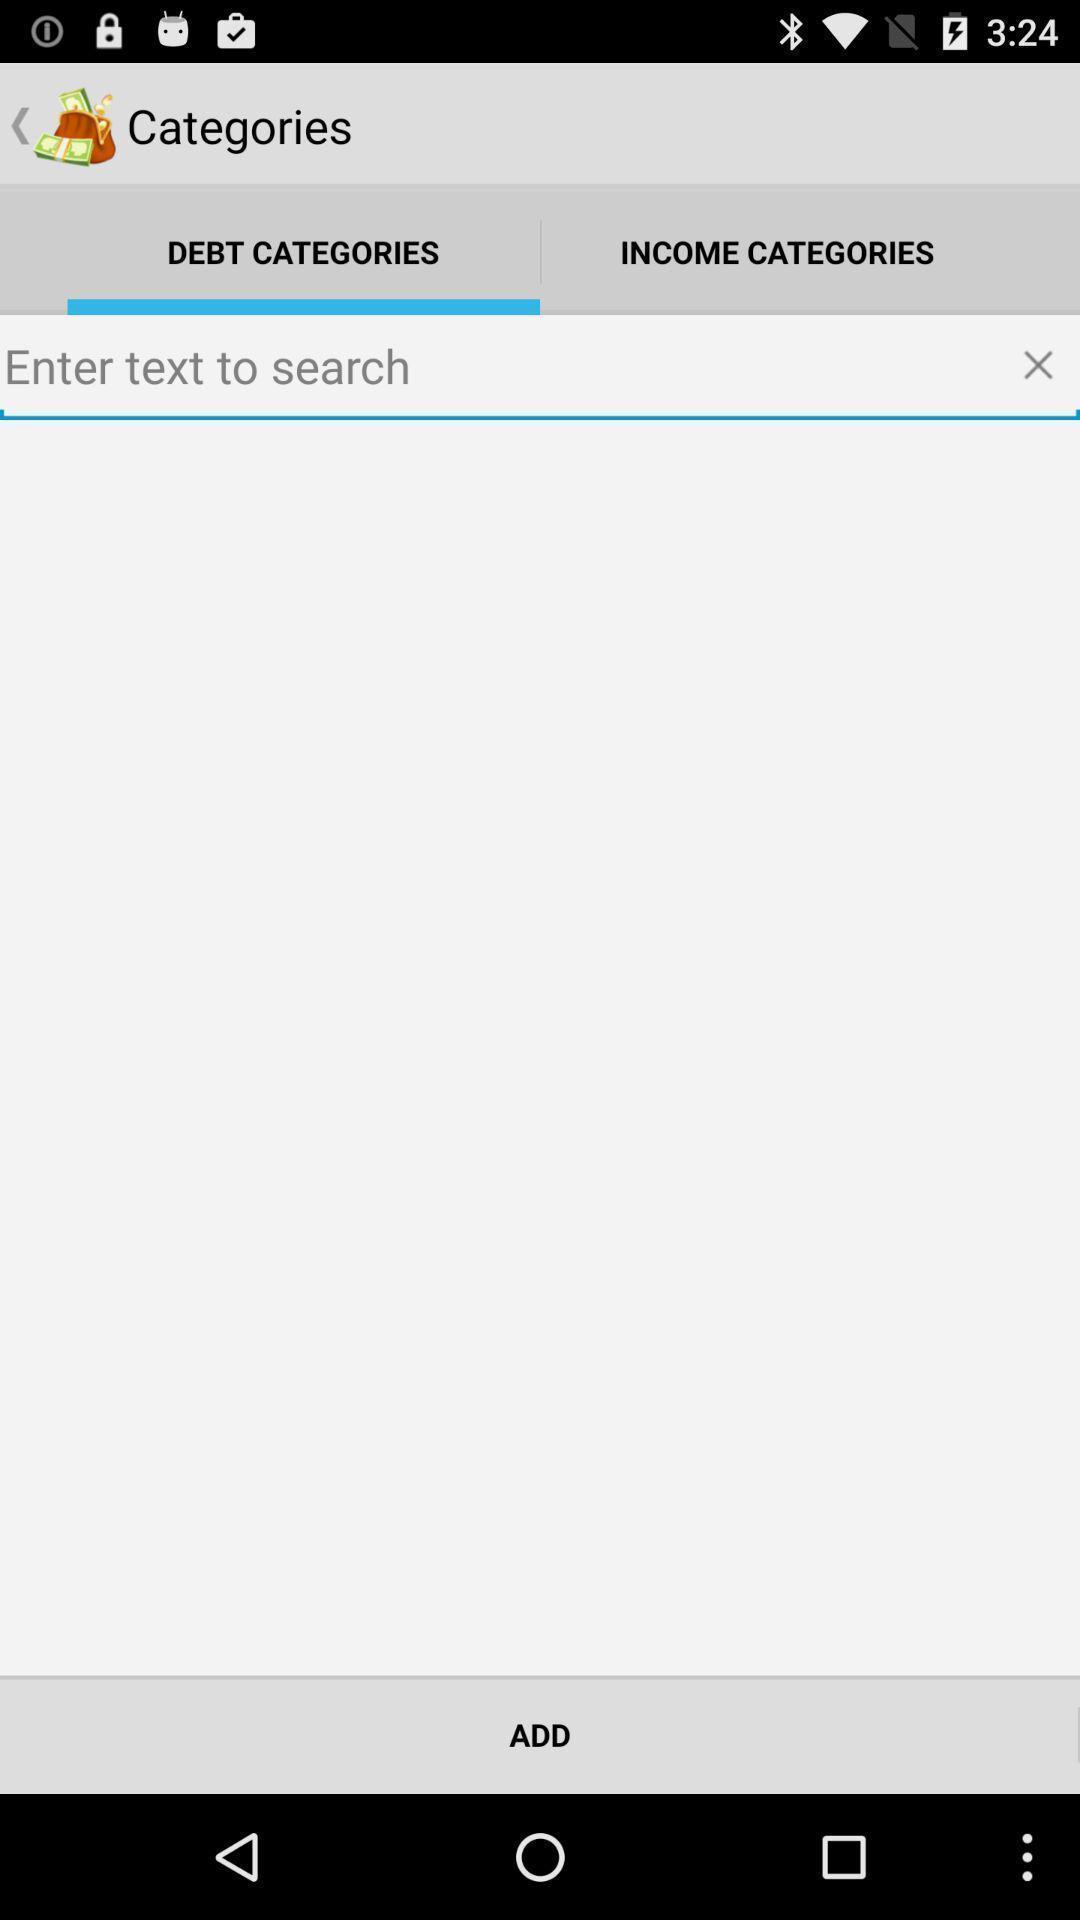Tell me what you see in this picture. Page that displays to add debt categories and other options. 